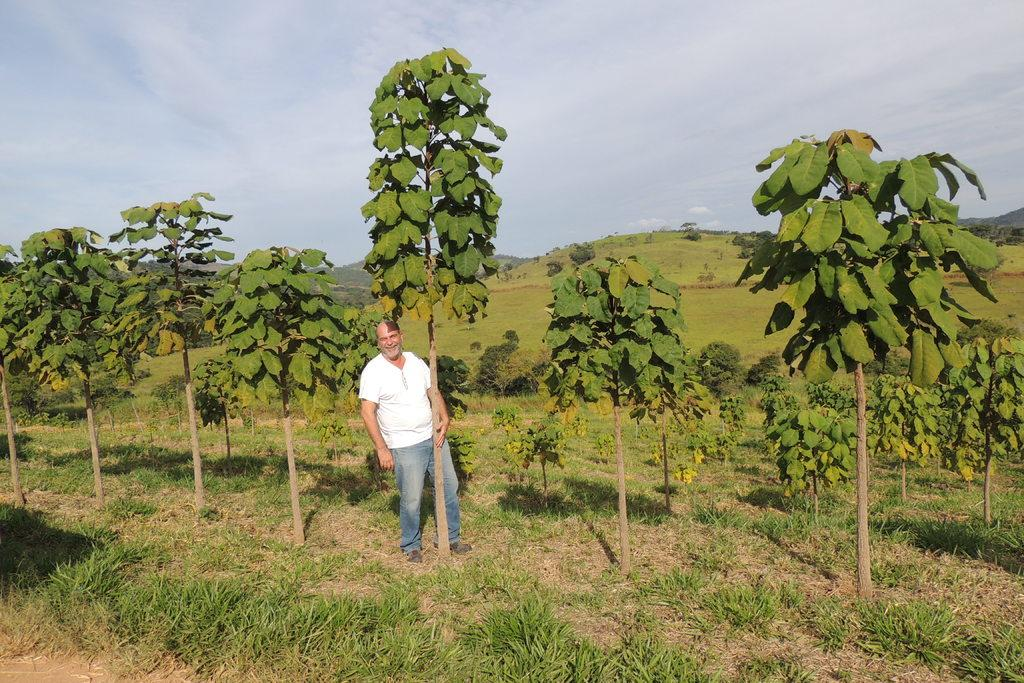What is the main subject of the image? There is a person standing in the image. What is the person standing on? The person is standing on grass. What type of natural environment is visible in the image? Trees and mountains are visible in the image. What is visible in the sky? The sky is visible in the image. What type of location might this image represent? The image may have been taken in a farm, given the presence of grass and the natural environment. What scientific discovery is the person making in the image? There is no indication in the image that the person is making a scientific discovery. 